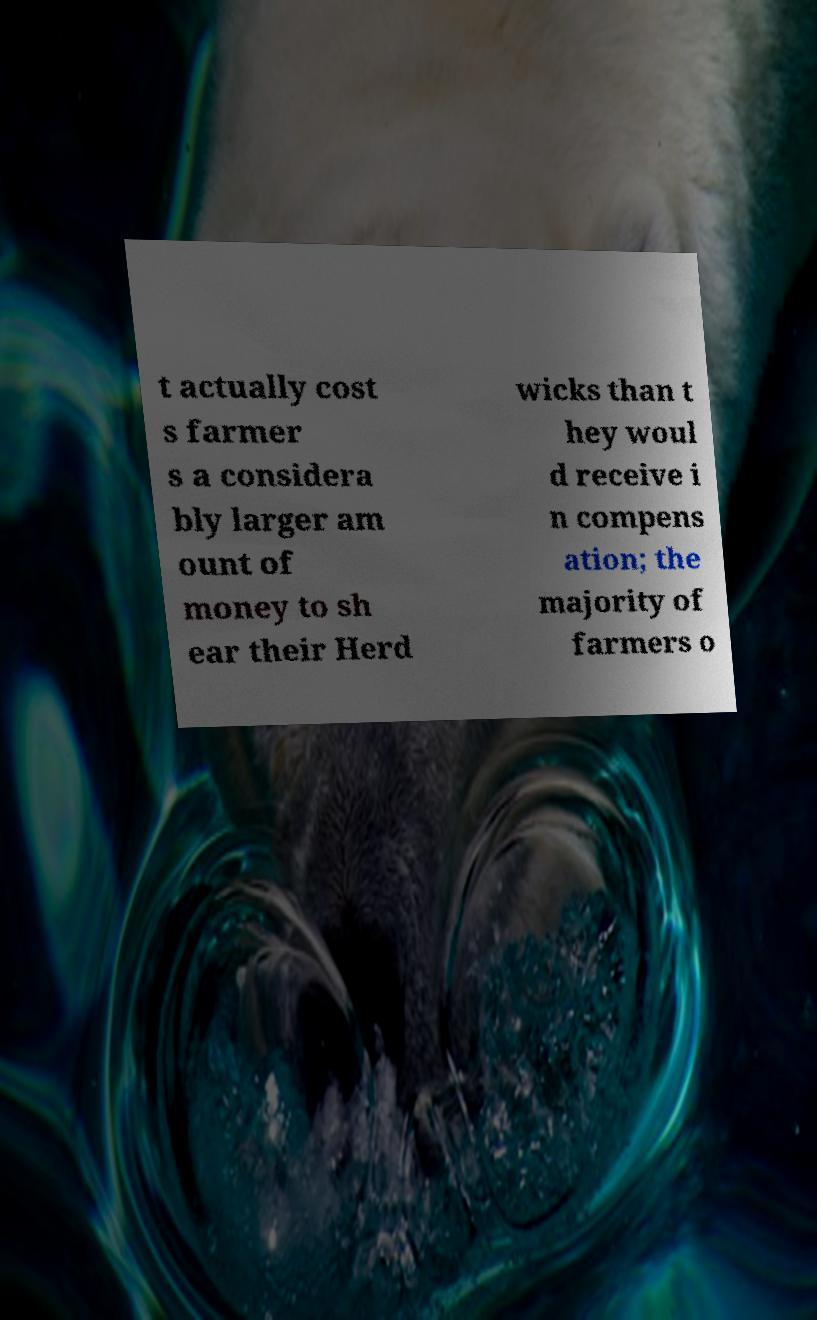Can you accurately transcribe the text from the provided image for me? t actually cost s farmer s a considera bly larger am ount of money to sh ear their Herd wicks than t hey woul d receive i n compens ation; the majority of farmers o 